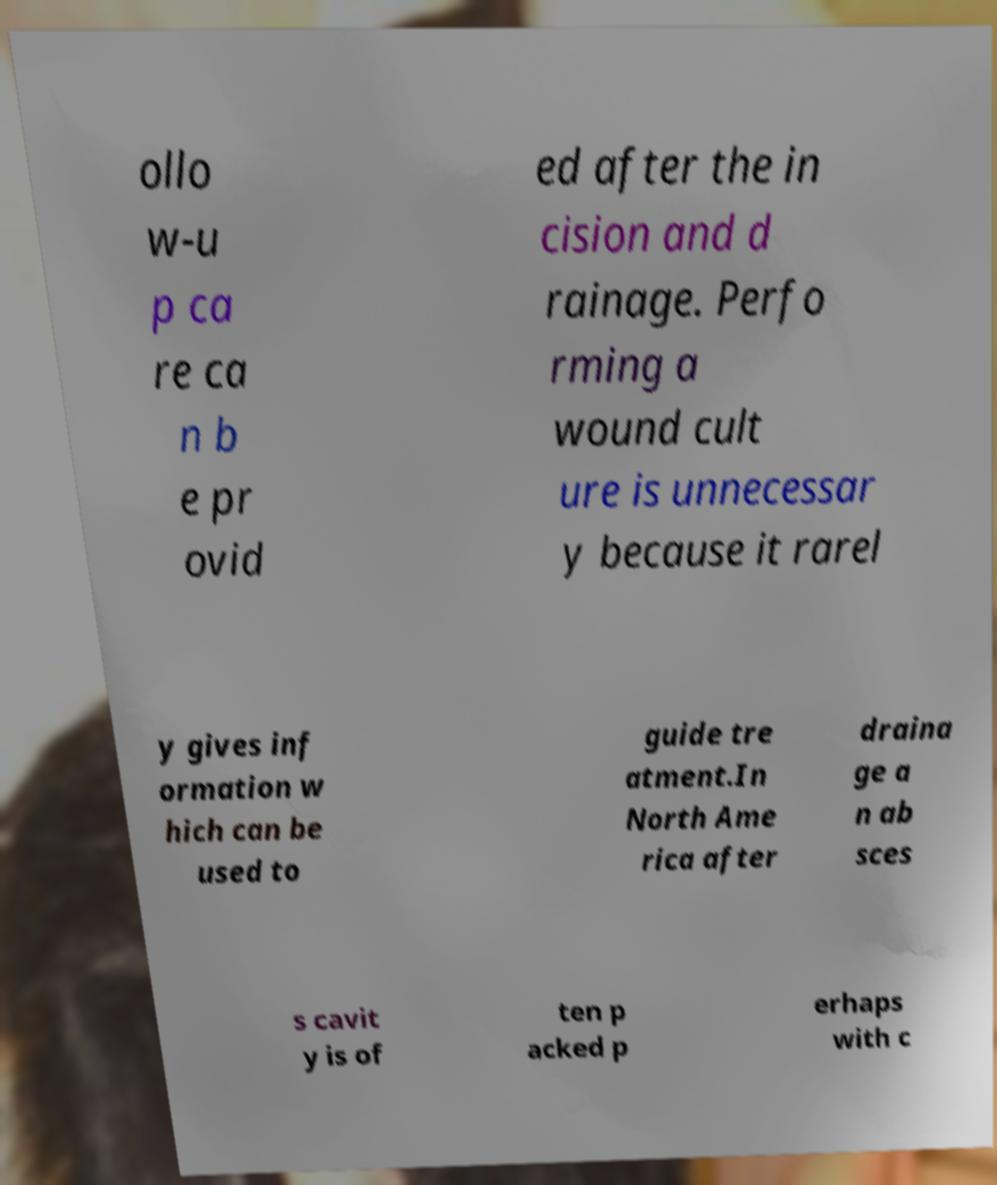Could you extract and type out the text from this image? ollo w-u p ca re ca n b e pr ovid ed after the in cision and d rainage. Perfo rming a wound cult ure is unnecessar y because it rarel y gives inf ormation w hich can be used to guide tre atment.In North Ame rica after draina ge a n ab sces s cavit y is of ten p acked p erhaps with c 